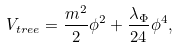<formula> <loc_0><loc_0><loc_500><loc_500>V _ { t r e e } = \frac { m ^ { 2 } } { 2 } \phi ^ { 2 } + \frac { \lambda _ { \Phi } } { 2 4 } \phi ^ { 4 } ,</formula> 